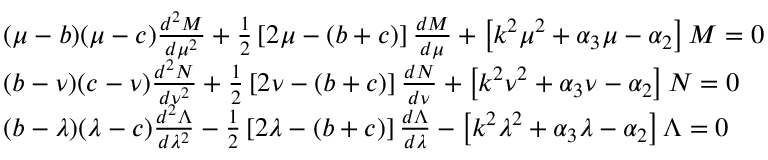<formula> <loc_0><loc_0><loc_500><loc_500>{ \begin{array} { r l } & { ( \mu - b ) ( \mu - c ) { \frac { d ^ { 2 } M } { d \mu ^ { 2 } } } + { \frac { 1 } { 2 } } \left [ 2 \mu - ( b + c ) \right ] { \frac { d M } { d \mu } } + \left [ k ^ { 2 } \mu ^ { 2 } + \alpha _ { 3 } \mu - \alpha _ { 2 } \right ] M = 0 } \\ & { ( b - \nu ) ( c - \nu ) { \frac { d ^ { 2 } N } { d \nu ^ { 2 } } } + { \frac { 1 } { 2 } } \left [ 2 \nu - ( b + c ) \right ] { \frac { d N } { d \nu } } + \left [ k ^ { 2 } \nu ^ { 2 } + \alpha _ { 3 } \nu - \alpha _ { 2 } \right ] N = 0 } \\ & { ( b - \lambda ) ( \lambda - c ) { \frac { d ^ { 2 } \Lambda } { d \lambda ^ { 2 } } } - { \frac { 1 } { 2 } } \left [ 2 \lambda - ( b + c ) \right ] { \frac { d \Lambda } { d \lambda } } - \left [ k ^ { 2 } \lambda ^ { 2 } + \alpha _ { 3 } \lambda - \alpha _ { 2 } \right ] \Lambda = 0 } \end{array} }</formula> 